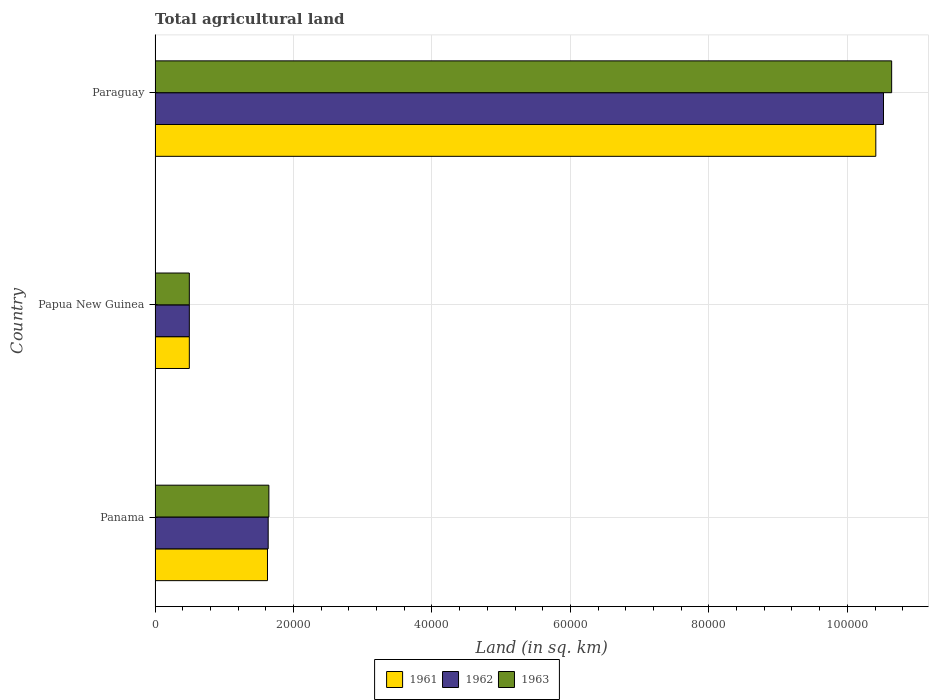How many groups of bars are there?
Your answer should be very brief. 3. Are the number of bars per tick equal to the number of legend labels?
Offer a very short reply. Yes. Are the number of bars on each tick of the Y-axis equal?
Ensure brevity in your answer.  Yes. How many bars are there on the 2nd tick from the top?
Keep it short and to the point. 3. How many bars are there on the 1st tick from the bottom?
Provide a short and direct response. 3. What is the label of the 3rd group of bars from the top?
Your response must be concise. Panama. What is the total agricultural land in 1963 in Panama?
Your response must be concise. 1.64e+04. Across all countries, what is the maximum total agricultural land in 1962?
Offer a very short reply. 1.05e+05. Across all countries, what is the minimum total agricultural land in 1962?
Your answer should be very brief. 4950. In which country was the total agricultural land in 1962 maximum?
Provide a short and direct response. Paraguay. In which country was the total agricultural land in 1963 minimum?
Your answer should be compact. Papua New Guinea. What is the total total agricultural land in 1962 in the graph?
Keep it short and to the point. 1.27e+05. What is the difference between the total agricultural land in 1962 in Papua New Guinea and that in Paraguay?
Make the answer very short. -1.00e+05. What is the difference between the total agricultural land in 1961 in Panama and the total agricultural land in 1962 in Papua New Guinea?
Your answer should be compact. 1.13e+04. What is the average total agricultural land in 1963 per country?
Ensure brevity in your answer.  4.26e+04. What is the difference between the total agricultural land in 1961 and total agricultural land in 1963 in Panama?
Ensure brevity in your answer.  -200. In how many countries, is the total agricultural land in 1961 greater than 88000 sq.km?
Offer a very short reply. 1. What is the ratio of the total agricultural land in 1961 in Panama to that in Papua New Guinea?
Provide a short and direct response. 3.28. Is the total agricultural land in 1963 in Panama less than that in Paraguay?
Your answer should be compact. Yes. Is the difference between the total agricultural land in 1961 in Papua New Guinea and Paraguay greater than the difference between the total agricultural land in 1963 in Papua New Guinea and Paraguay?
Keep it short and to the point. Yes. What is the difference between the highest and the second highest total agricultural land in 1963?
Offer a very short reply. 9.00e+04. What is the difference between the highest and the lowest total agricultural land in 1963?
Make the answer very short. 1.01e+05. Is the sum of the total agricultural land in 1961 in Papua New Guinea and Paraguay greater than the maximum total agricultural land in 1962 across all countries?
Your answer should be compact. Yes. Is it the case that in every country, the sum of the total agricultural land in 1961 and total agricultural land in 1963 is greater than the total agricultural land in 1962?
Your response must be concise. Yes. How many bars are there?
Offer a very short reply. 9. How many countries are there in the graph?
Your response must be concise. 3. What is the difference between two consecutive major ticks on the X-axis?
Offer a terse response. 2.00e+04. Does the graph contain grids?
Ensure brevity in your answer.  Yes. Where does the legend appear in the graph?
Offer a terse response. Bottom center. How many legend labels are there?
Give a very brief answer. 3. How are the legend labels stacked?
Make the answer very short. Horizontal. What is the title of the graph?
Provide a succinct answer. Total agricultural land. What is the label or title of the X-axis?
Make the answer very short. Land (in sq. km). What is the label or title of the Y-axis?
Provide a succinct answer. Country. What is the Land (in sq. km) of 1961 in Panama?
Offer a very short reply. 1.62e+04. What is the Land (in sq. km) in 1962 in Panama?
Your response must be concise. 1.63e+04. What is the Land (in sq. km) of 1963 in Panama?
Ensure brevity in your answer.  1.64e+04. What is the Land (in sq. km) of 1961 in Papua New Guinea?
Your answer should be compact. 4950. What is the Land (in sq. km) in 1962 in Papua New Guinea?
Your response must be concise. 4950. What is the Land (in sq. km) in 1963 in Papua New Guinea?
Your answer should be very brief. 4950. What is the Land (in sq. km) in 1961 in Paraguay?
Make the answer very short. 1.04e+05. What is the Land (in sq. km) of 1962 in Paraguay?
Give a very brief answer. 1.05e+05. What is the Land (in sq. km) in 1963 in Paraguay?
Provide a succinct answer. 1.06e+05. Across all countries, what is the maximum Land (in sq. km) in 1961?
Your answer should be compact. 1.04e+05. Across all countries, what is the maximum Land (in sq. km) of 1962?
Offer a very short reply. 1.05e+05. Across all countries, what is the maximum Land (in sq. km) in 1963?
Your answer should be very brief. 1.06e+05. Across all countries, what is the minimum Land (in sq. km) in 1961?
Make the answer very short. 4950. Across all countries, what is the minimum Land (in sq. km) of 1962?
Provide a succinct answer. 4950. Across all countries, what is the minimum Land (in sq. km) in 1963?
Your answer should be compact. 4950. What is the total Land (in sq. km) of 1961 in the graph?
Ensure brevity in your answer.  1.25e+05. What is the total Land (in sq. km) in 1962 in the graph?
Make the answer very short. 1.27e+05. What is the total Land (in sq. km) of 1963 in the graph?
Provide a short and direct response. 1.28e+05. What is the difference between the Land (in sq. km) of 1961 in Panama and that in Papua New Guinea?
Give a very brief answer. 1.13e+04. What is the difference between the Land (in sq. km) of 1962 in Panama and that in Papua New Guinea?
Offer a very short reply. 1.14e+04. What is the difference between the Land (in sq. km) of 1963 in Panama and that in Papua New Guinea?
Keep it short and to the point. 1.15e+04. What is the difference between the Land (in sq. km) of 1961 in Panama and that in Paraguay?
Provide a succinct answer. -8.79e+04. What is the difference between the Land (in sq. km) of 1962 in Panama and that in Paraguay?
Your answer should be compact. -8.89e+04. What is the difference between the Land (in sq. km) of 1963 in Panama and that in Paraguay?
Offer a terse response. -9.00e+04. What is the difference between the Land (in sq. km) of 1961 in Papua New Guinea and that in Paraguay?
Provide a succinct answer. -9.92e+04. What is the difference between the Land (in sq. km) in 1962 in Papua New Guinea and that in Paraguay?
Keep it short and to the point. -1.00e+05. What is the difference between the Land (in sq. km) of 1963 in Papua New Guinea and that in Paraguay?
Offer a very short reply. -1.01e+05. What is the difference between the Land (in sq. km) in 1961 in Panama and the Land (in sq. km) in 1962 in Papua New Guinea?
Offer a terse response. 1.13e+04. What is the difference between the Land (in sq. km) in 1961 in Panama and the Land (in sq. km) in 1963 in Papua New Guinea?
Provide a short and direct response. 1.13e+04. What is the difference between the Land (in sq. km) in 1962 in Panama and the Land (in sq. km) in 1963 in Papua New Guinea?
Your response must be concise. 1.14e+04. What is the difference between the Land (in sq. km) in 1961 in Panama and the Land (in sq. km) in 1962 in Paraguay?
Your answer should be very brief. -8.90e+04. What is the difference between the Land (in sq. km) of 1961 in Panama and the Land (in sq. km) of 1963 in Paraguay?
Provide a short and direct response. -9.02e+04. What is the difference between the Land (in sq. km) in 1962 in Panama and the Land (in sq. km) in 1963 in Paraguay?
Your response must be concise. -9.01e+04. What is the difference between the Land (in sq. km) in 1961 in Papua New Guinea and the Land (in sq. km) in 1962 in Paraguay?
Make the answer very short. -1.00e+05. What is the difference between the Land (in sq. km) of 1961 in Papua New Guinea and the Land (in sq. km) of 1963 in Paraguay?
Provide a succinct answer. -1.01e+05. What is the difference between the Land (in sq. km) of 1962 in Papua New Guinea and the Land (in sq. km) of 1963 in Paraguay?
Give a very brief answer. -1.01e+05. What is the average Land (in sq. km) of 1961 per country?
Your response must be concise. 4.18e+04. What is the average Land (in sq. km) of 1962 per country?
Provide a short and direct response. 4.22e+04. What is the average Land (in sq. km) in 1963 per country?
Provide a succinct answer. 4.26e+04. What is the difference between the Land (in sq. km) in 1961 and Land (in sq. km) in 1962 in Panama?
Your answer should be very brief. -100. What is the difference between the Land (in sq. km) of 1961 and Land (in sq. km) of 1963 in Panama?
Offer a terse response. -200. What is the difference between the Land (in sq. km) in 1962 and Land (in sq. km) in 1963 in Panama?
Make the answer very short. -100. What is the difference between the Land (in sq. km) in 1961 and Land (in sq. km) in 1962 in Papua New Guinea?
Provide a short and direct response. 0. What is the difference between the Land (in sq. km) of 1962 and Land (in sq. km) of 1963 in Papua New Guinea?
Give a very brief answer. 0. What is the difference between the Land (in sq. km) in 1961 and Land (in sq. km) in 1962 in Paraguay?
Provide a succinct answer. -1110. What is the difference between the Land (in sq. km) in 1961 and Land (in sq. km) in 1963 in Paraguay?
Provide a short and direct response. -2290. What is the difference between the Land (in sq. km) of 1962 and Land (in sq. km) of 1963 in Paraguay?
Give a very brief answer. -1180. What is the ratio of the Land (in sq. km) in 1961 in Panama to that in Papua New Guinea?
Make the answer very short. 3.28. What is the ratio of the Land (in sq. km) in 1962 in Panama to that in Papua New Guinea?
Ensure brevity in your answer.  3.3. What is the ratio of the Land (in sq. km) of 1963 in Panama to that in Papua New Guinea?
Ensure brevity in your answer.  3.32. What is the ratio of the Land (in sq. km) in 1961 in Panama to that in Paraguay?
Your response must be concise. 0.16. What is the ratio of the Land (in sq. km) of 1962 in Panama to that in Paraguay?
Provide a short and direct response. 0.16. What is the ratio of the Land (in sq. km) in 1963 in Panama to that in Paraguay?
Your answer should be very brief. 0.15. What is the ratio of the Land (in sq. km) of 1961 in Papua New Guinea to that in Paraguay?
Keep it short and to the point. 0.05. What is the ratio of the Land (in sq. km) in 1962 in Papua New Guinea to that in Paraguay?
Your response must be concise. 0.05. What is the ratio of the Land (in sq. km) of 1963 in Papua New Guinea to that in Paraguay?
Your answer should be very brief. 0.05. What is the difference between the highest and the second highest Land (in sq. km) in 1961?
Your answer should be compact. 8.79e+04. What is the difference between the highest and the second highest Land (in sq. km) in 1962?
Ensure brevity in your answer.  8.89e+04. What is the difference between the highest and the second highest Land (in sq. km) in 1963?
Offer a terse response. 9.00e+04. What is the difference between the highest and the lowest Land (in sq. km) in 1961?
Make the answer very short. 9.92e+04. What is the difference between the highest and the lowest Land (in sq. km) in 1962?
Ensure brevity in your answer.  1.00e+05. What is the difference between the highest and the lowest Land (in sq. km) in 1963?
Offer a very short reply. 1.01e+05. 